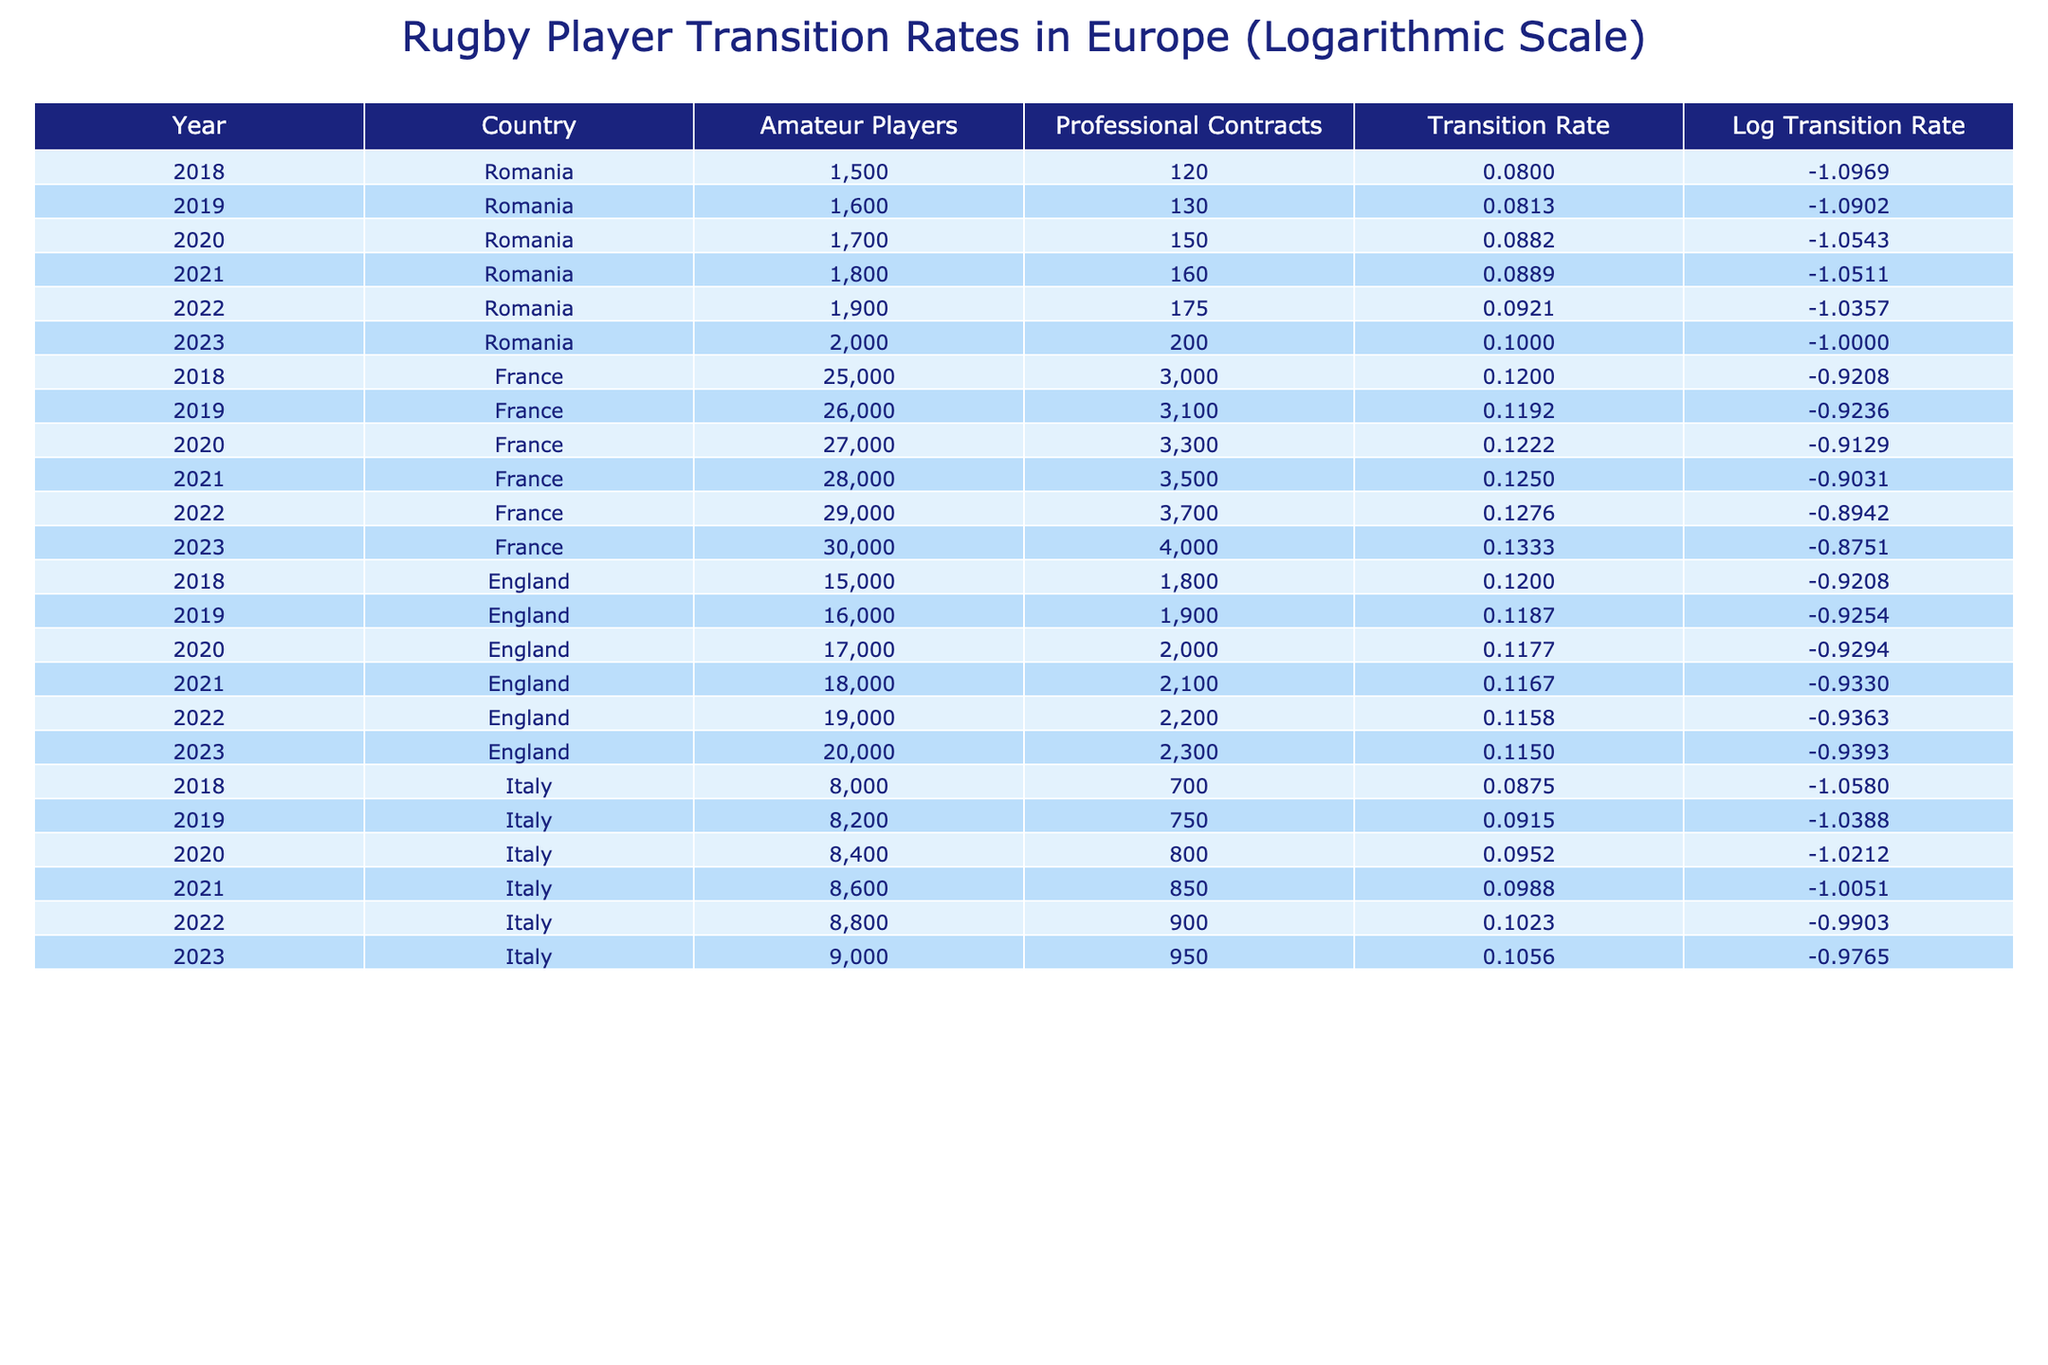What was the highest transition rate in Romania between 2018 and 2023? The highest transition rate for Romania during this period can be found by checking the Transition Rate column and identifying the maximum value. The maximum value is 0.1 from the year 2023.
Answer: 0.1 What is the number of professional contracts in France in 2020? By looking at the corresponding row for France in the year 2020, the value in the Professional Contracts column is 3300.
Answer: 3300 How many amateur players were there in Italy in 2021? The number of amateur players for Italy can be directly retrieved from the table for the year 2021, which shows there were 8600 amateur players.
Answer: 8600 What is the average transition rate across all countries in 2022? To find the average transition rate for 2022, sum the transition rates for each country (0.09211 + 0.12759 + 0.11579 + 0.10227) and divide it by 4 (the number of countries). The total sum is 0.43776, which gives an average of 0.10944.
Answer: 0.10944 Is the transition rate for England decreasing from 2018 to 2023? We can see the transition rates for England from 2018 (0.12) to 2023 (0.115). Since 0.115 is less than 0.12, this means the transition rate is indeed decreasing during this period.
Answer: Yes Which country had the lowest transition rate in 2019? Checking the Transition Rate column for 2019, Romania (0.08125) has a lower transition rate compared to France (0.11923), England (0.11875), and Italy (0.09146). Thus, Romania had the lowest transition rate in 2019.
Answer: Romania What was the total number of amateur players across all countries in 2023? For the total number of amateur players in 2023, we sum the values: 2000 (Romania) + 30000 (France) + 20000 (England) + 9000 (Italy) = 49000.
Answer: 49000 What is the trend of transition rates from 2018 to 2023 in Romania? By examining the Transition Rate figures for Romania from 2018 (0.08) to 2023 (0.1), there is a visible increase each year, indicating a consistent upward trend in transition rates during this period.
Answer: Increasing Which country experienced the most significant increase in professional contracts from 2018 to 2023? To find this, we calculate the difference in professional contracts from 2018 to 2023 for each country: Romania (120 to 200 = 80), France (3000 to 4000 = 1000), England (1800 to 2300 = 500), and Italy (700 to 950 = 250). France had the largest increase of 1000 contracts.
Answer: France 